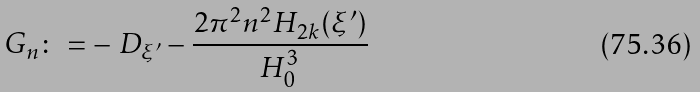<formula> <loc_0><loc_0><loc_500><loc_500>G _ { n } \colon = - \ D _ { \xi ^ { \prime } } - \frac { 2 \pi ^ { 2 } n ^ { 2 } H _ { 2 k } ( \xi ^ { \prime } ) } { H _ { 0 } ^ { 3 } }</formula> 